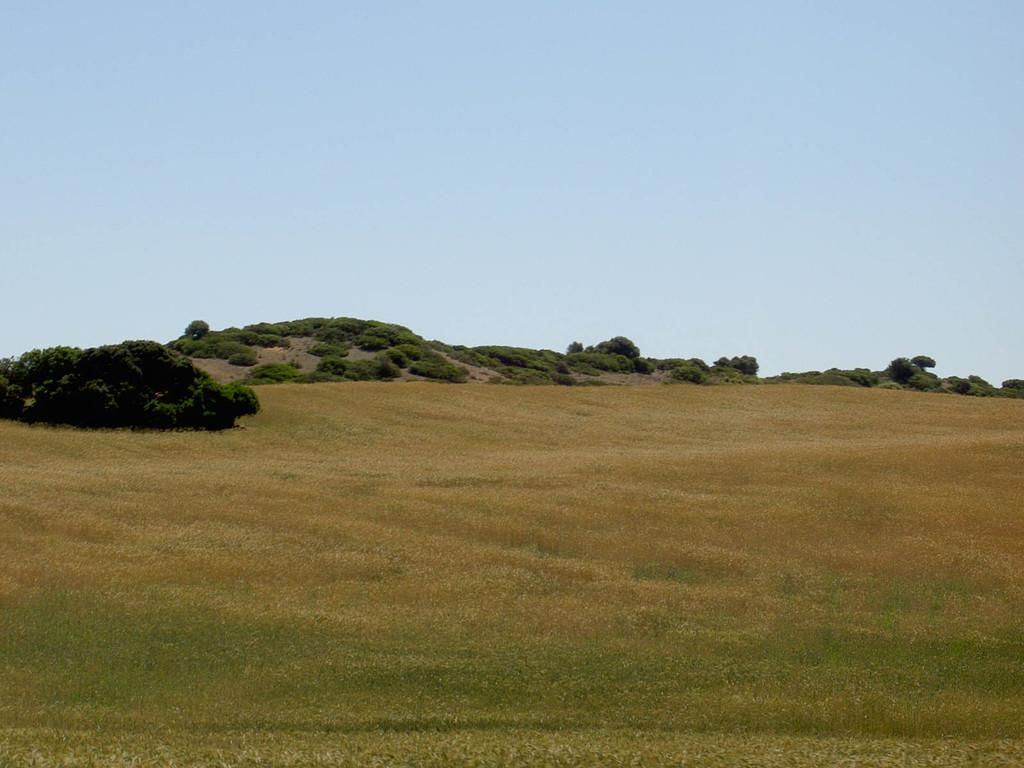What type of vegetation can be seen in the image? There are trees and grass in the image. What is the terrain like in the image? There is a hill in the image. What is visible in the background of the image? The sky is visible in the image. How would you describe the weather based on the sky in the image? The sky appears cloudy in the image. What type of protest is taking place on the hill in the image? There is no protest present in the image; it features trees, grass, a hill, and a cloudy sky. What kind of lighting system is used to illuminate the trees in the image? There is no lighting system present in the image; it is a natural scene with trees, grass, a hill, and a cloudy sky. 